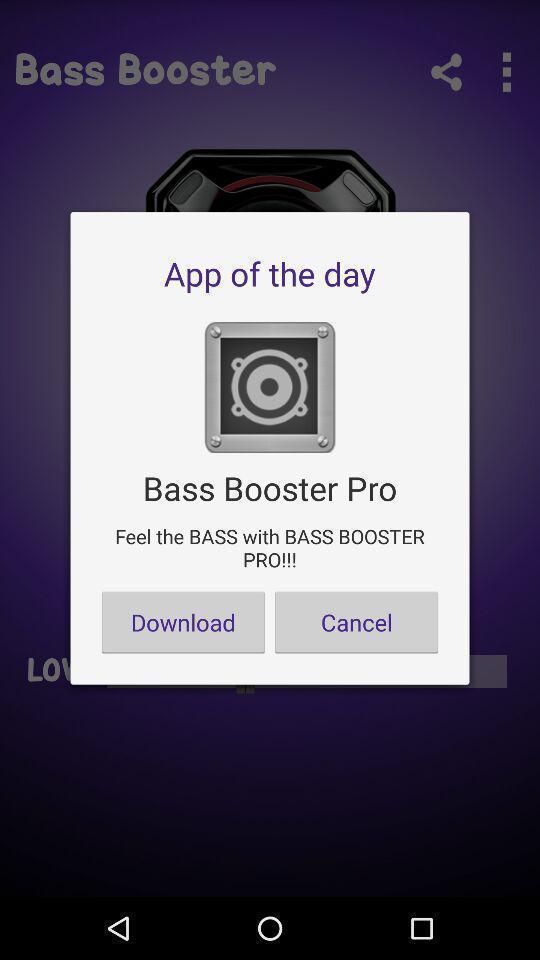Provide a detailed account of this screenshot. Popup showing information about app to download. 